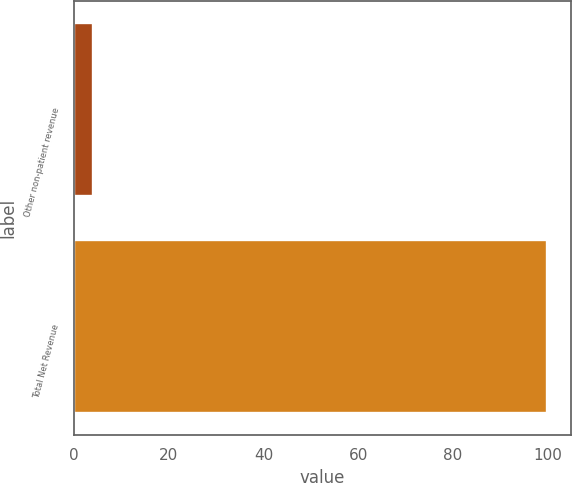<chart> <loc_0><loc_0><loc_500><loc_500><bar_chart><fcel>Other non-patient revenue<fcel>Total Net Revenue<nl><fcel>4<fcel>100<nl></chart> 